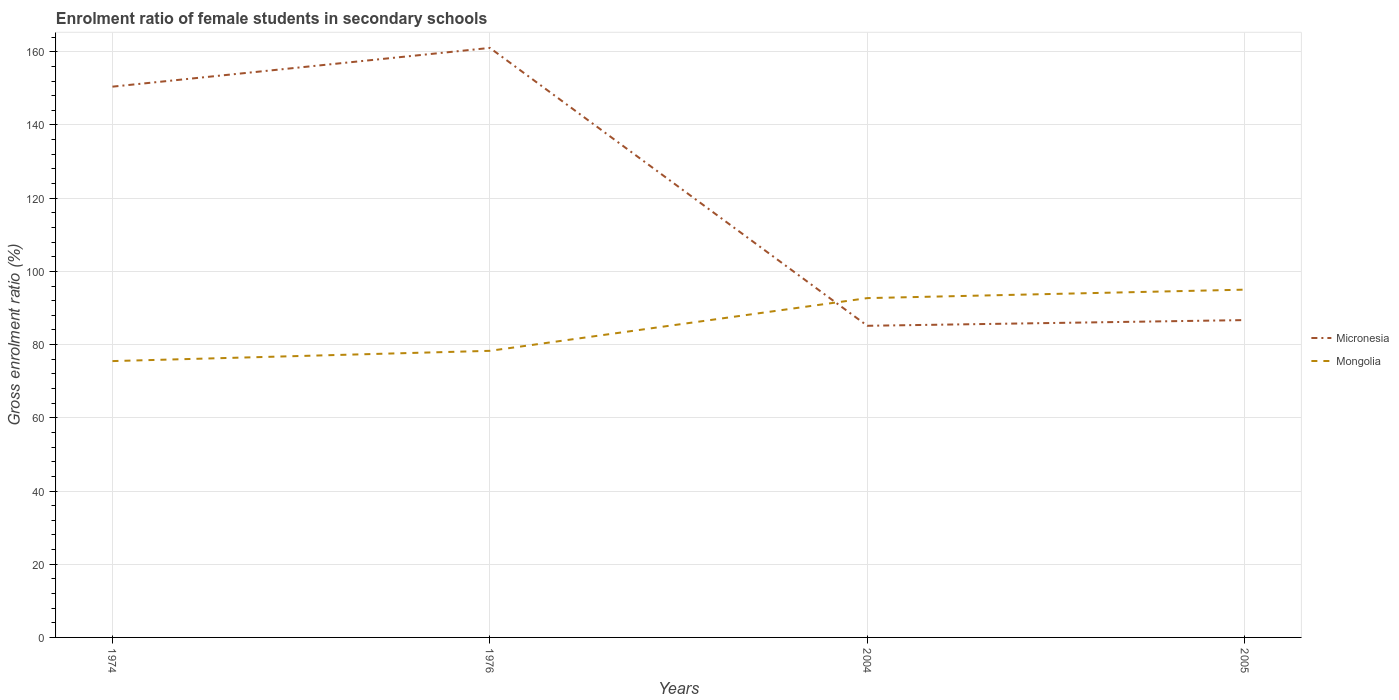Is the number of lines equal to the number of legend labels?
Keep it short and to the point. Yes. Across all years, what is the maximum enrolment ratio of female students in secondary schools in Micronesia?
Your response must be concise. 85.14. In which year was the enrolment ratio of female students in secondary schools in Mongolia maximum?
Ensure brevity in your answer.  1974. What is the total enrolment ratio of female students in secondary schools in Micronesia in the graph?
Make the answer very short. 74.36. What is the difference between the highest and the second highest enrolment ratio of female students in secondary schools in Mongolia?
Give a very brief answer. 19.52. Is the enrolment ratio of female students in secondary schools in Mongolia strictly greater than the enrolment ratio of female students in secondary schools in Micronesia over the years?
Give a very brief answer. No. How many years are there in the graph?
Keep it short and to the point. 4. What is the difference between two consecutive major ticks on the Y-axis?
Make the answer very short. 20. Does the graph contain any zero values?
Your answer should be very brief. No. Does the graph contain grids?
Your answer should be compact. Yes. Where does the legend appear in the graph?
Provide a short and direct response. Center right. How many legend labels are there?
Your response must be concise. 2. What is the title of the graph?
Offer a very short reply. Enrolment ratio of female students in secondary schools. What is the label or title of the X-axis?
Your answer should be compact. Years. What is the label or title of the Y-axis?
Offer a very short reply. Gross enrolment ratio (%). What is the Gross enrolment ratio (%) in Micronesia in 1974?
Ensure brevity in your answer.  150.47. What is the Gross enrolment ratio (%) in Mongolia in 1974?
Your answer should be compact. 75.49. What is the Gross enrolment ratio (%) in Micronesia in 1976?
Keep it short and to the point. 161.05. What is the Gross enrolment ratio (%) of Mongolia in 1976?
Provide a short and direct response. 78.3. What is the Gross enrolment ratio (%) in Micronesia in 2004?
Ensure brevity in your answer.  85.14. What is the Gross enrolment ratio (%) of Mongolia in 2004?
Provide a short and direct response. 92.7. What is the Gross enrolment ratio (%) in Micronesia in 2005?
Your answer should be very brief. 86.69. What is the Gross enrolment ratio (%) of Mongolia in 2005?
Your answer should be compact. 95.01. Across all years, what is the maximum Gross enrolment ratio (%) of Micronesia?
Offer a terse response. 161.05. Across all years, what is the maximum Gross enrolment ratio (%) in Mongolia?
Offer a terse response. 95.01. Across all years, what is the minimum Gross enrolment ratio (%) of Micronesia?
Keep it short and to the point. 85.14. Across all years, what is the minimum Gross enrolment ratio (%) of Mongolia?
Make the answer very short. 75.49. What is the total Gross enrolment ratio (%) in Micronesia in the graph?
Offer a very short reply. 483.35. What is the total Gross enrolment ratio (%) of Mongolia in the graph?
Your response must be concise. 341.5. What is the difference between the Gross enrolment ratio (%) of Micronesia in 1974 and that in 1976?
Offer a terse response. -10.59. What is the difference between the Gross enrolment ratio (%) of Mongolia in 1974 and that in 1976?
Make the answer very short. -2.8. What is the difference between the Gross enrolment ratio (%) in Micronesia in 1974 and that in 2004?
Offer a terse response. 65.33. What is the difference between the Gross enrolment ratio (%) in Mongolia in 1974 and that in 2004?
Make the answer very short. -17.2. What is the difference between the Gross enrolment ratio (%) of Micronesia in 1974 and that in 2005?
Your response must be concise. 63.77. What is the difference between the Gross enrolment ratio (%) of Mongolia in 1974 and that in 2005?
Provide a succinct answer. -19.52. What is the difference between the Gross enrolment ratio (%) in Micronesia in 1976 and that in 2004?
Keep it short and to the point. 75.91. What is the difference between the Gross enrolment ratio (%) of Mongolia in 1976 and that in 2004?
Offer a terse response. -14.4. What is the difference between the Gross enrolment ratio (%) in Micronesia in 1976 and that in 2005?
Provide a short and direct response. 74.36. What is the difference between the Gross enrolment ratio (%) in Mongolia in 1976 and that in 2005?
Keep it short and to the point. -16.71. What is the difference between the Gross enrolment ratio (%) of Micronesia in 2004 and that in 2005?
Your answer should be compact. -1.56. What is the difference between the Gross enrolment ratio (%) of Mongolia in 2004 and that in 2005?
Keep it short and to the point. -2.31. What is the difference between the Gross enrolment ratio (%) in Micronesia in 1974 and the Gross enrolment ratio (%) in Mongolia in 1976?
Your answer should be very brief. 72.17. What is the difference between the Gross enrolment ratio (%) of Micronesia in 1974 and the Gross enrolment ratio (%) of Mongolia in 2004?
Provide a short and direct response. 57.77. What is the difference between the Gross enrolment ratio (%) in Micronesia in 1974 and the Gross enrolment ratio (%) in Mongolia in 2005?
Offer a very short reply. 55.46. What is the difference between the Gross enrolment ratio (%) in Micronesia in 1976 and the Gross enrolment ratio (%) in Mongolia in 2004?
Make the answer very short. 68.35. What is the difference between the Gross enrolment ratio (%) of Micronesia in 1976 and the Gross enrolment ratio (%) of Mongolia in 2005?
Give a very brief answer. 66.04. What is the difference between the Gross enrolment ratio (%) in Micronesia in 2004 and the Gross enrolment ratio (%) in Mongolia in 2005?
Provide a short and direct response. -9.87. What is the average Gross enrolment ratio (%) in Micronesia per year?
Your answer should be compact. 120.84. What is the average Gross enrolment ratio (%) in Mongolia per year?
Provide a succinct answer. 85.38. In the year 1974, what is the difference between the Gross enrolment ratio (%) of Micronesia and Gross enrolment ratio (%) of Mongolia?
Your response must be concise. 74.97. In the year 1976, what is the difference between the Gross enrolment ratio (%) of Micronesia and Gross enrolment ratio (%) of Mongolia?
Make the answer very short. 82.75. In the year 2004, what is the difference between the Gross enrolment ratio (%) in Micronesia and Gross enrolment ratio (%) in Mongolia?
Provide a succinct answer. -7.56. In the year 2005, what is the difference between the Gross enrolment ratio (%) in Micronesia and Gross enrolment ratio (%) in Mongolia?
Your answer should be very brief. -8.32. What is the ratio of the Gross enrolment ratio (%) of Micronesia in 1974 to that in 1976?
Make the answer very short. 0.93. What is the ratio of the Gross enrolment ratio (%) in Mongolia in 1974 to that in 1976?
Give a very brief answer. 0.96. What is the ratio of the Gross enrolment ratio (%) of Micronesia in 1974 to that in 2004?
Your answer should be very brief. 1.77. What is the ratio of the Gross enrolment ratio (%) of Mongolia in 1974 to that in 2004?
Your answer should be very brief. 0.81. What is the ratio of the Gross enrolment ratio (%) in Micronesia in 1974 to that in 2005?
Your response must be concise. 1.74. What is the ratio of the Gross enrolment ratio (%) of Mongolia in 1974 to that in 2005?
Your answer should be compact. 0.79. What is the ratio of the Gross enrolment ratio (%) in Micronesia in 1976 to that in 2004?
Your answer should be compact. 1.89. What is the ratio of the Gross enrolment ratio (%) in Mongolia in 1976 to that in 2004?
Provide a short and direct response. 0.84. What is the ratio of the Gross enrolment ratio (%) in Micronesia in 1976 to that in 2005?
Provide a succinct answer. 1.86. What is the ratio of the Gross enrolment ratio (%) of Mongolia in 1976 to that in 2005?
Your response must be concise. 0.82. What is the ratio of the Gross enrolment ratio (%) of Micronesia in 2004 to that in 2005?
Offer a very short reply. 0.98. What is the ratio of the Gross enrolment ratio (%) of Mongolia in 2004 to that in 2005?
Your answer should be very brief. 0.98. What is the difference between the highest and the second highest Gross enrolment ratio (%) of Micronesia?
Your answer should be compact. 10.59. What is the difference between the highest and the second highest Gross enrolment ratio (%) in Mongolia?
Provide a short and direct response. 2.31. What is the difference between the highest and the lowest Gross enrolment ratio (%) of Micronesia?
Your answer should be very brief. 75.91. What is the difference between the highest and the lowest Gross enrolment ratio (%) in Mongolia?
Offer a very short reply. 19.52. 